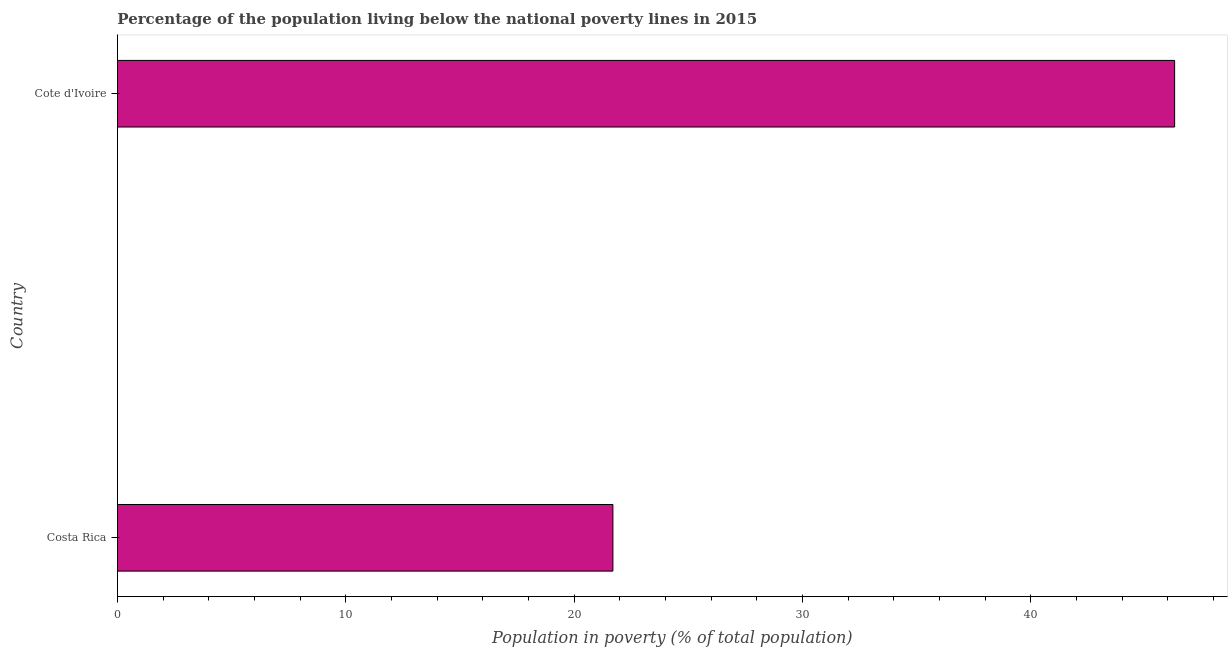What is the title of the graph?
Your response must be concise. Percentage of the population living below the national poverty lines in 2015. What is the label or title of the X-axis?
Your answer should be very brief. Population in poverty (% of total population). What is the percentage of population living below poverty line in Cote d'Ivoire?
Your answer should be very brief. 46.3. Across all countries, what is the maximum percentage of population living below poverty line?
Provide a succinct answer. 46.3. Across all countries, what is the minimum percentage of population living below poverty line?
Offer a terse response. 21.7. In which country was the percentage of population living below poverty line maximum?
Your answer should be very brief. Cote d'Ivoire. What is the difference between the percentage of population living below poverty line in Costa Rica and Cote d'Ivoire?
Keep it short and to the point. -24.6. In how many countries, is the percentage of population living below poverty line greater than 34 %?
Give a very brief answer. 1. What is the ratio of the percentage of population living below poverty line in Costa Rica to that in Cote d'Ivoire?
Your response must be concise. 0.47. Is the percentage of population living below poverty line in Costa Rica less than that in Cote d'Ivoire?
Offer a terse response. Yes. In how many countries, is the percentage of population living below poverty line greater than the average percentage of population living below poverty line taken over all countries?
Your answer should be compact. 1. Are all the bars in the graph horizontal?
Your response must be concise. Yes. Are the values on the major ticks of X-axis written in scientific E-notation?
Keep it short and to the point. No. What is the Population in poverty (% of total population) in Costa Rica?
Offer a terse response. 21.7. What is the Population in poverty (% of total population) in Cote d'Ivoire?
Provide a succinct answer. 46.3. What is the difference between the Population in poverty (% of total population) in Costa Rica and Cote d'Ivoire?
Make the answer very short. -24.6. What is the ratio of the Population in poverty (% of total population) in Costa Rica to that in Cote d'Ivoire?
Your answer should be compact. 0.47. 